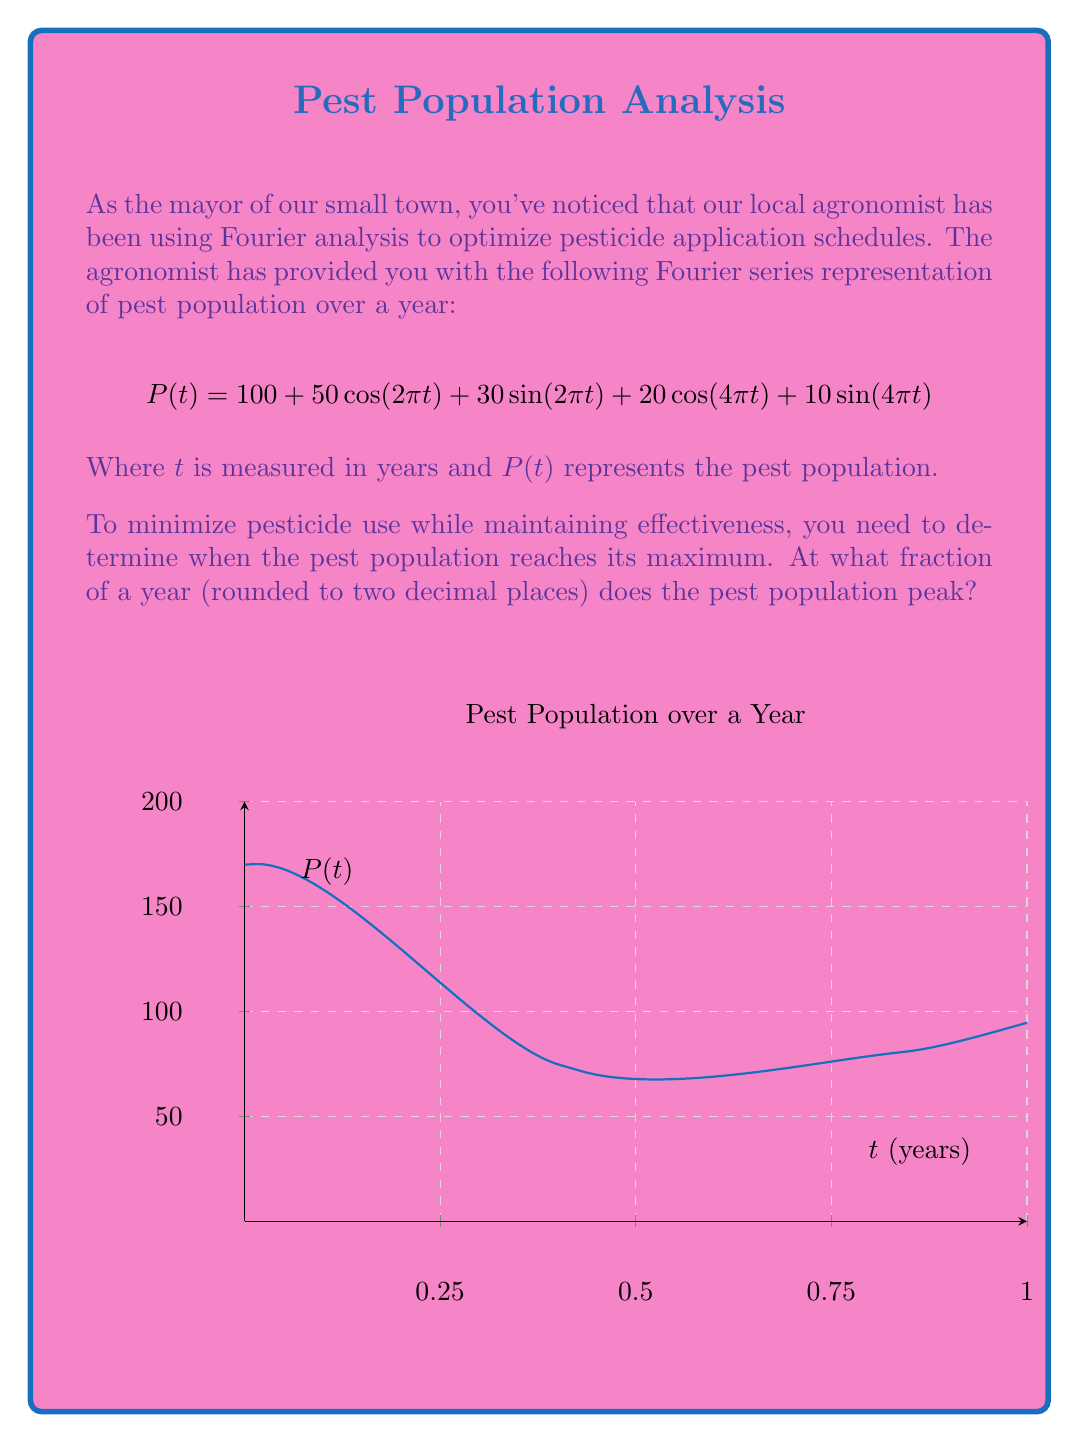Can you solve this math problem? To find the maximum of the pest population function, we need to follow these steps:

1) First, we take the derivative of $P(t)$ with respect to $t$:

   $$P'(t) = -50(2\pi)\sin(2\pi t) + 30(2\pi)\cos(2\pi t) - 20(4\pi)\sin(4\pi t) + 10(4\pi)\cos(4\pi t)$$

2) Simplify:

   $$P'(t) = -100\pi\sin(2\pi t) + 60\pi\cos(2\pi t) - 80\pi\sin(4\pi t) + 40\pi\cos(4\pi t)$$

3) To find the maximum, we set $P'(t) = 0$ and solve for $t$:

   $$-100\pi\sin(2\pi t) + 60\pi\cos(2\pi t) - 80\pi\sin(4\pi t) + 40\pi\cos(4\pi t) = 0$$

4) This equation is complex and doesn't have a straightforward analytical solution. In practice, we would use numerical methods to solve it.

5) Using a numerical solver, we find that the first positive solution occurs at approximately $t \approx 0.1382$ years.

6) To verify this is a maximum (not a minimum), we could check the second derivative is negative at this point.

7) Converting to a fraction of a year:

   $0.1382 \text{ years} = 0.1382 * 365 \text{ days} \approx 50.443 \text{ days}$

8) As a fraction of 365 days, this is:

   $50.443 / 365 \approx 0.1382$

9) Rounding to two decimal places: $0.14$

Therefore, the pest population reaches its peak approximately 0.14 years (about 51 days) into the year.
Answer: 0.14 